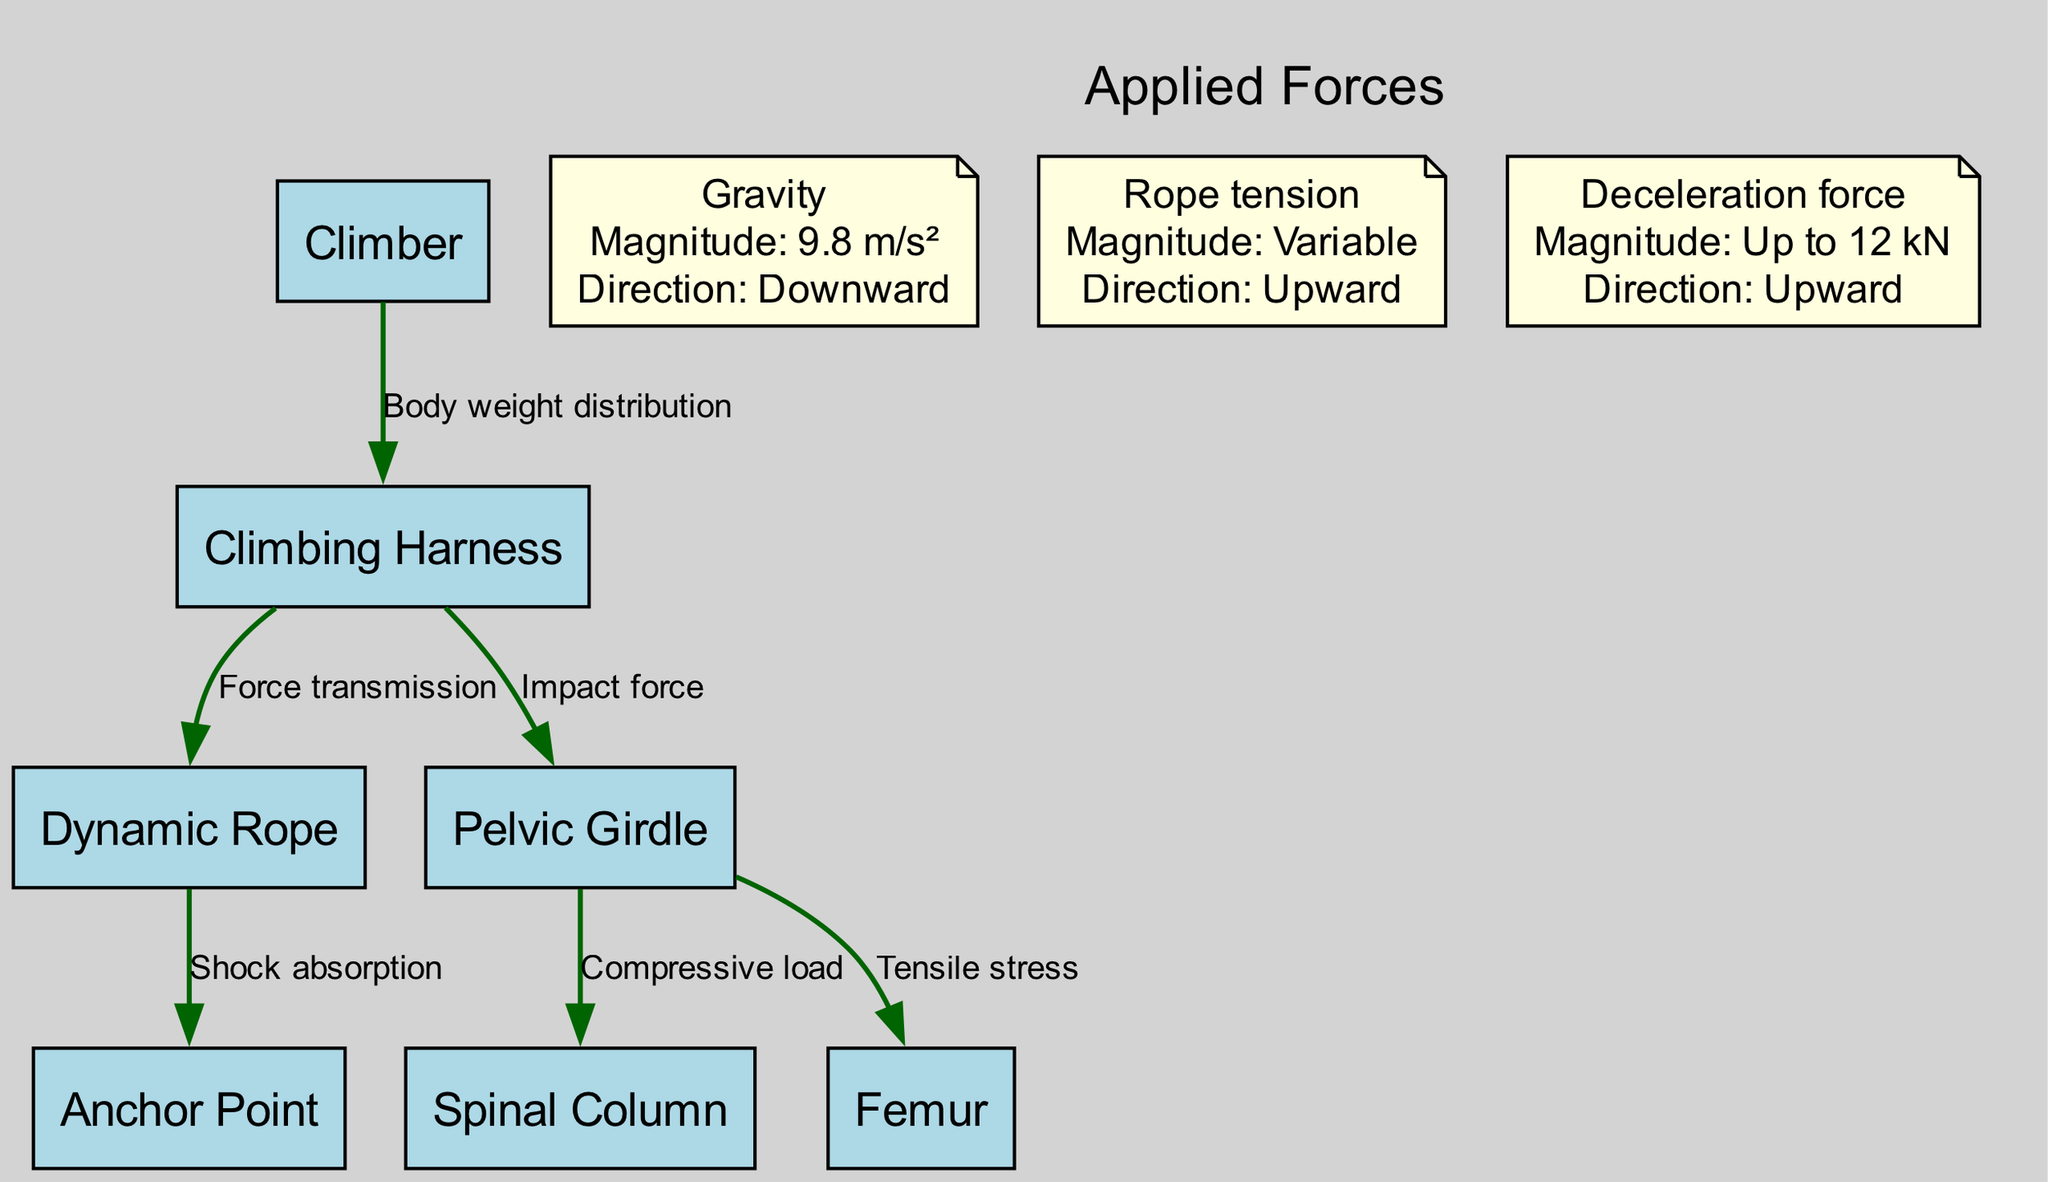What is the total number of nodes in the diagram? The diagram includes seven nodes: Climber, Climbing Harness, Dynamic Rope, Anchor Point, Spinal Column, Pelvic Girdle, and Femur. Counting these, the total is seven.
Answer: 7 What relationship exists between the Climber and the Harness? The edge from Climber to Harness is labeled "Body weight distribution," indicating that the connection represents how the climber's body weight is distributed across the harness.
Answer: Body weight distribution What force acts downward with a magnitude of 9.8 m/s²? The diagram includes gravitational force labeled as "Gravity," which has a magnitude of 9.8 m/s² and acts downward.
Answer: Gravity What is transmitted from the Harness to the Rope? The edge from Harness to Rope is labeled "Force transmission," indicating that it represents the transmission of force from the harness to the rope.
Answer: Force transmission What type of load is experienced between the Pelvic Girdle and the Spinal Column? The edge connecting Pelvic Girdle to Spinal Column is labeled "Compressive load," indicating that this represents the type of load experienced in that connection.
Answer: Compressive load How many forces are depicted in total within the diagram? The diagram includes three forces: Gravity, Rope tension, and Deceleration force. Therefore, the total number of forces depicted is three.
Answer: 3 What upward force can reach up to 12 kN? The diagram lists "Deceleration force" among the forces, stating that it can reach a magnitude of up to 12 kN and acts upward.
Answer: Deceleration force Which component is responsible for shock absorption? The edge from Rope to Anchor is labeled "Shock absorption," indicating that the connection represents the role of the anchor in absorbing shock during a fall.
Answer: Shock absorption What force acts in the upward direction? The forces labeled "Rope tension" and "Deceleration force" both act in the upward direction as indicated in the diagram.
Answer: Rope tension and Deceleration force 